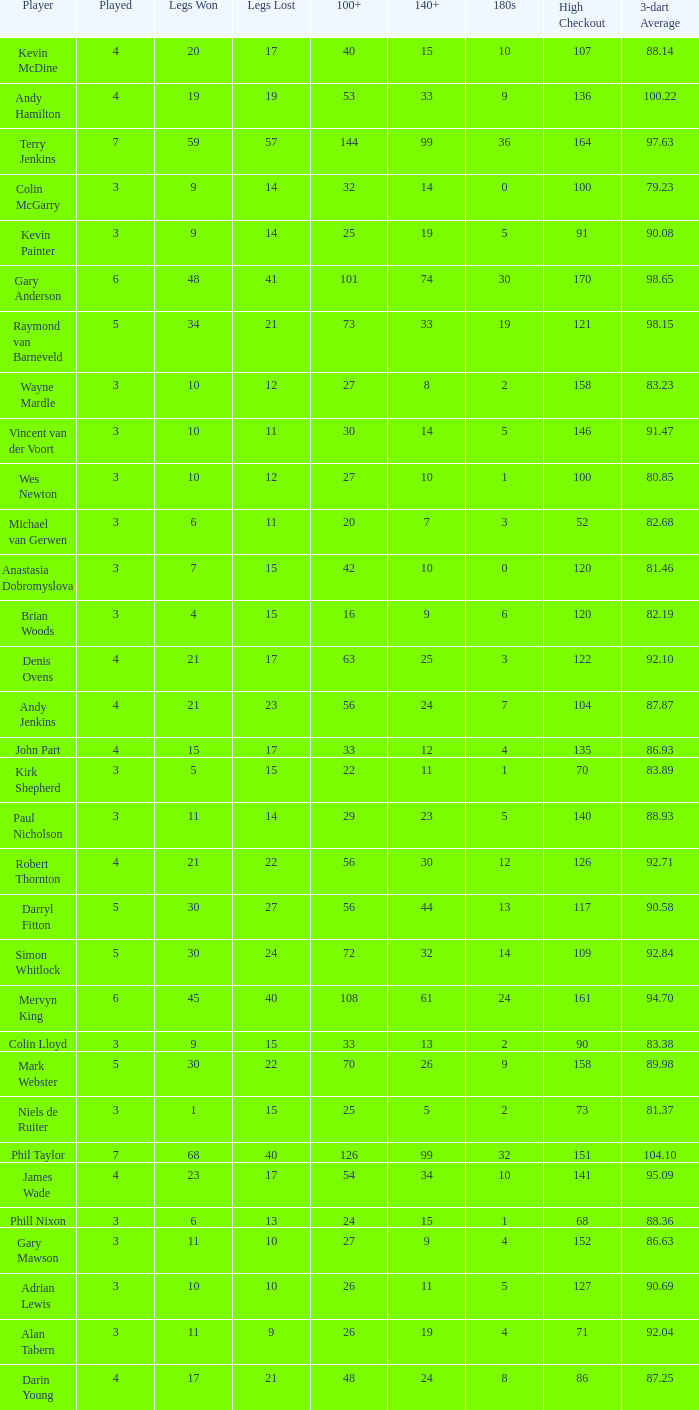What is the lowest high checkout when 140+ is 61, and played is larger than 6? None. 